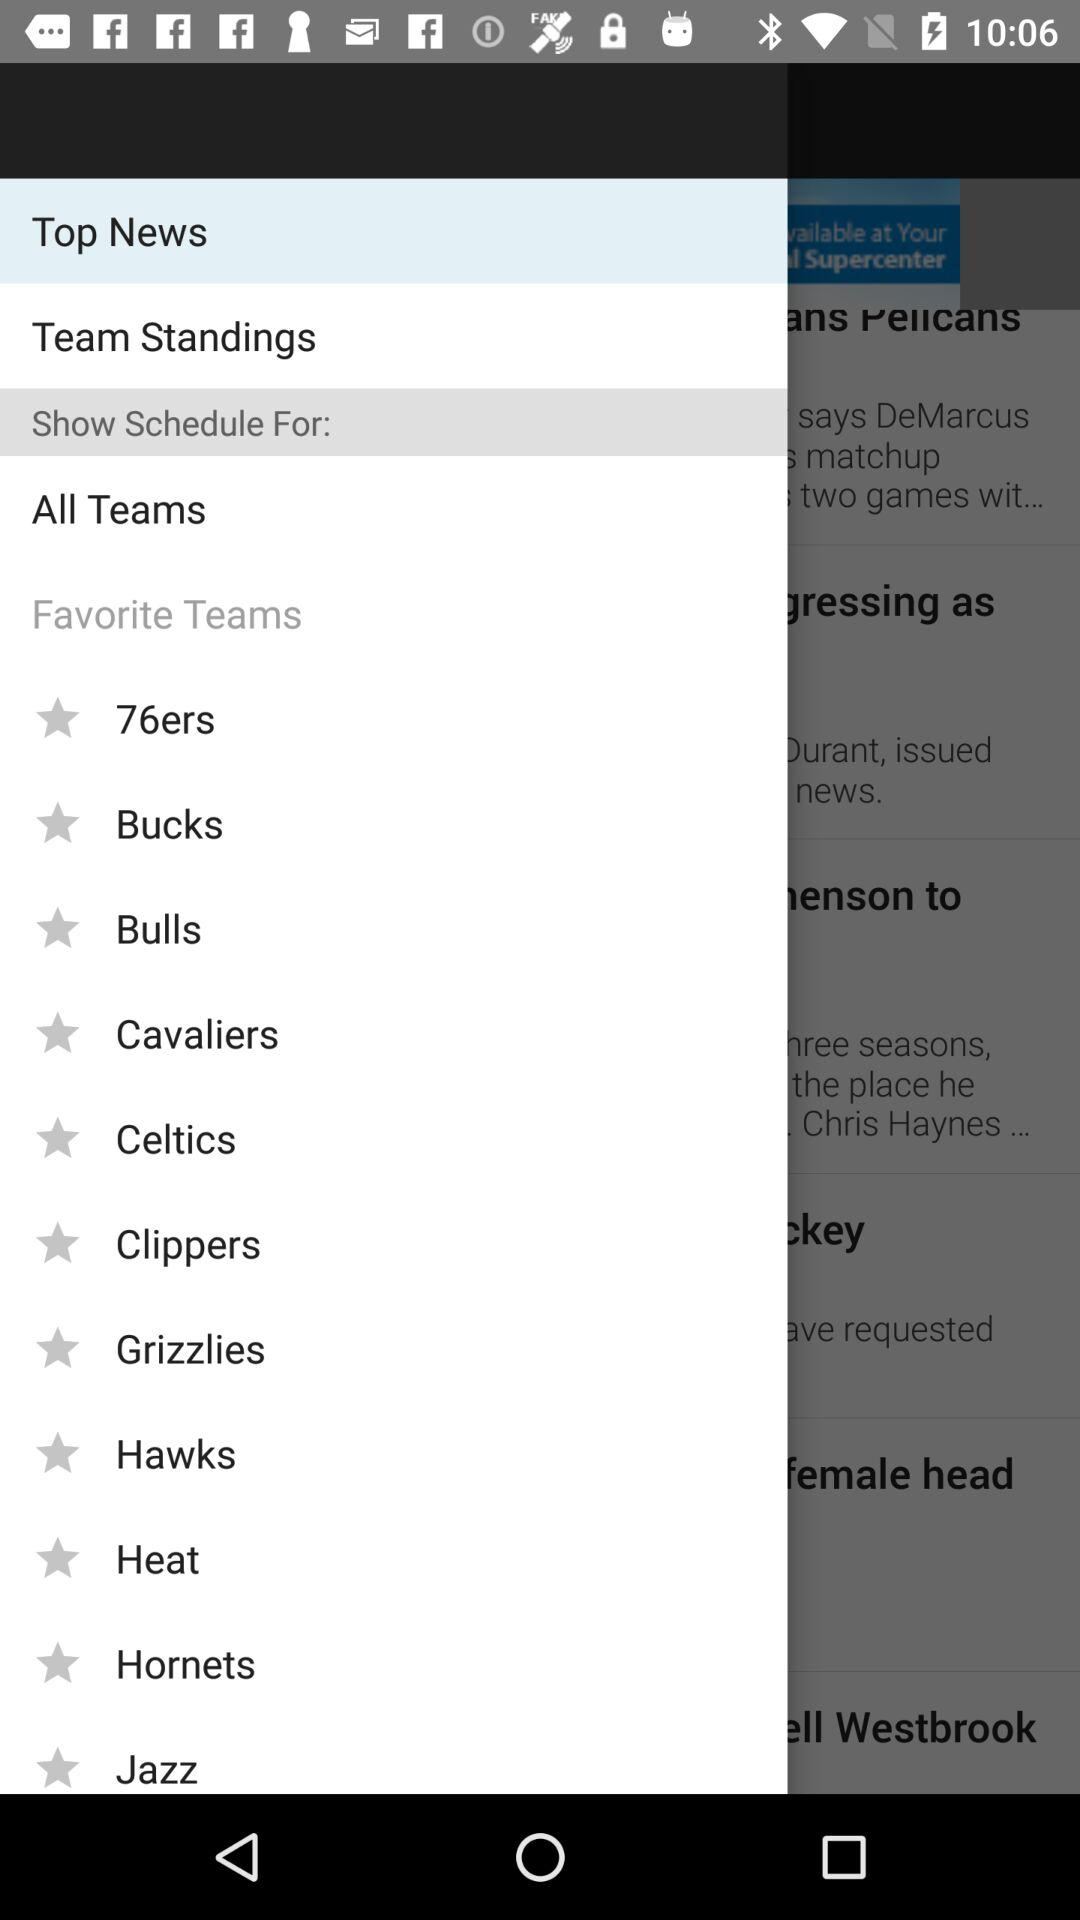When was the latest sports story published?
When the provided information is insufficient, respond with <no answer>. <no answer> 